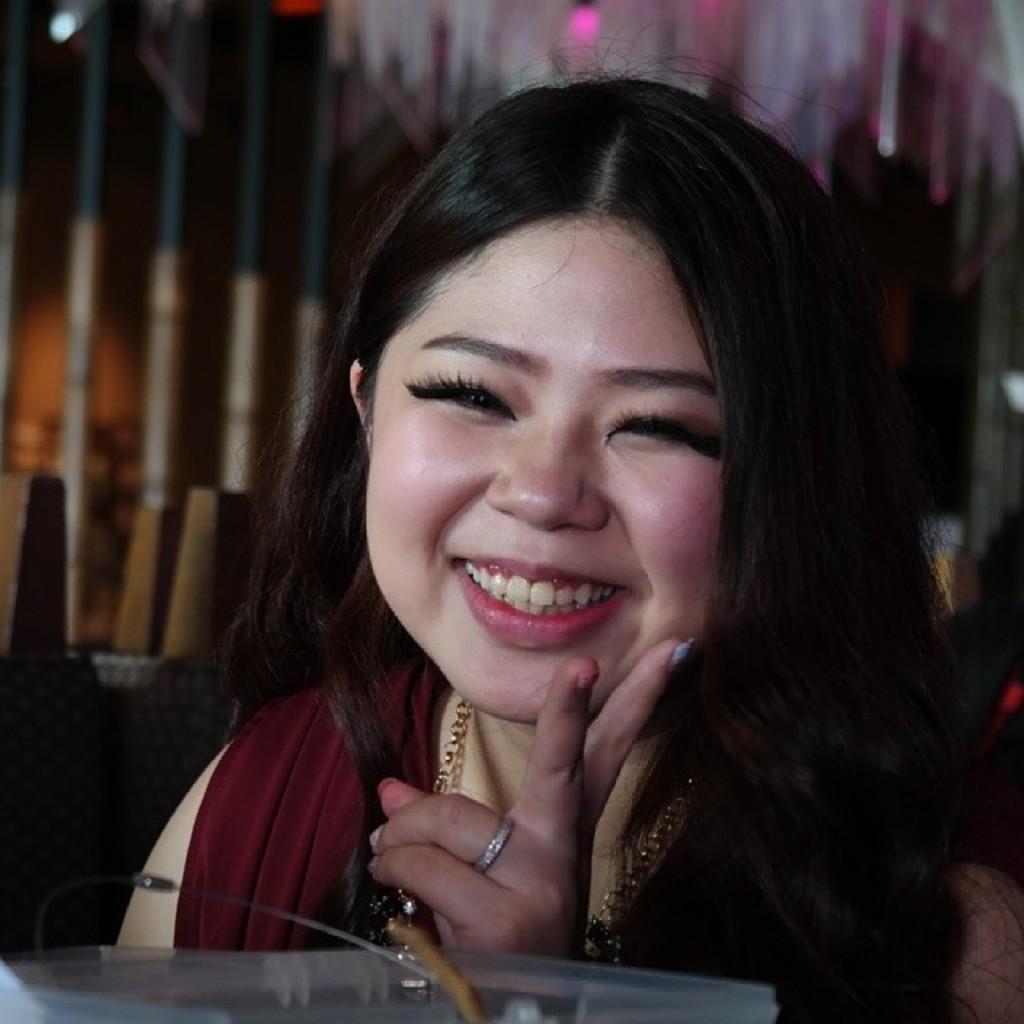In one or two sentences, can you explain what this image depicts? In the picture I can see a woman wearing maroon color dress, chain and ring to the finger is smiling. The background of the image is dark and slightly blurred, where we can see few objects. 